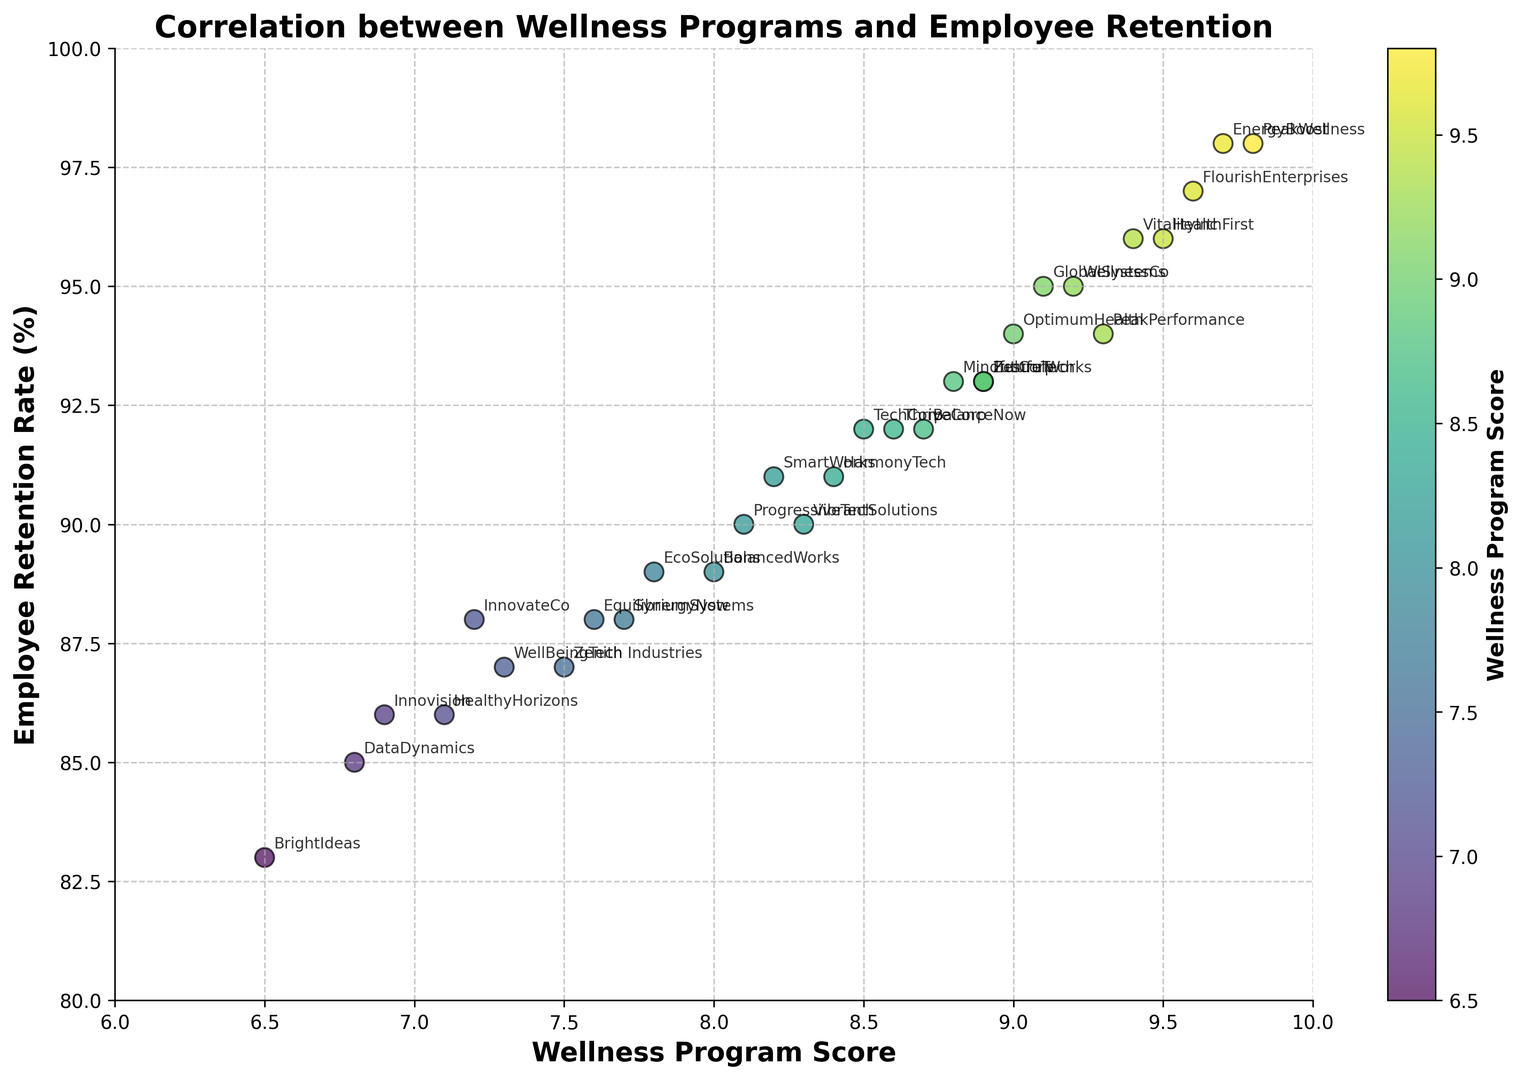What is the wellness program score of the company with the highest employee retention rate? The company with the highest employee retention rate is EnergyBoost and PeakWellness, both with a retention rate of 98%. According to the plot, EnergyBoost has a wellness program score of 9.7, and PeakWellness has a score of 9.8.
Answer: 9.7 and 9.8 Which company has the lowest employee retention rate, and what is its wellness program score? Referring to the plot, the company with the lowest employee retention rate is BrightIdeas, with a retention rate of 83%. Its wellness program score is 6.5.
Answer: BrightIdeas, 6.5 What is the average wellness program score for companies with an employee retention rate of 95% or higher? The companies with a retention rate of 95% or higher are GlobalSystems (9.1), HealthFirst (9.5), WellnessCo (9.2), VitalityInc (9.4), FlourishEnterprises (9.6), EnergyBoost (9.7), and PeakWellness (9.8). Calculating the average: (9.1 + 9.5 + 9.2 + 9.4 + 9.6 + 9.7 + 9.8) / 7 = 66.3 / 7 = 9.47.
Answer: 9.47 Is there a company with a wellness program score less than 7 and an employee retention rate above 85%? From the visual plot, HealthyHorizons and Innovision have wellness program scores less than 7. Among them, Innovision has an employee retention rate of 86%.
Answer: Yes, Innovision Which company shows the most significant increase in employee retention with a wellness program score increase from the 7 to 9 range? Comparing companies across the 7 to 9 wellness program scores, DataDynamics has a score of 6.8 and a retention rate of 85%, whereas WellnessCo has a score of 9.2 and a retention rate of 95%. This results in the most significant increment in retention rate of 10% going from the 7 range to the 9 range.
Answer: WellnessCo How many companies have an employee retention rate between 90% and 95%? Observing the plot, the companies with retention rates between 90% and 95% are TechCorp, FutureTech, SmartWorks, PeakPerformance, OptimumHealth, BalanceNow, HarmonyTech, ProgressiveTech, VibrantSolutions, and Zenith Industries. This counts up to 10 companies.
Answer: 10 Which company has a wellness program score closest to the median of all wellness program scores? What is its retention rate? Ordering the program scores: 6.5, 6.8, 6.9, 7.1, 7.2, 7.3, 7.5, 7.6, 7.7, 7.8, 8.0, 8.1, 8.2, 8.3, 8.4, 8.5, 8.6, 8.7, 8.8, 8.9, 8.9, 9.0, 9.1, 9.2, 9.3, 9.4, 9.5, 9.6, 9.7, 9.8. The middle value (median) is 8.45. HarmonyTech has a wellness program score of 8.4 which is closest to 8.45 and its retention rate is 91%.
Answer: HarmonyTech, 91 